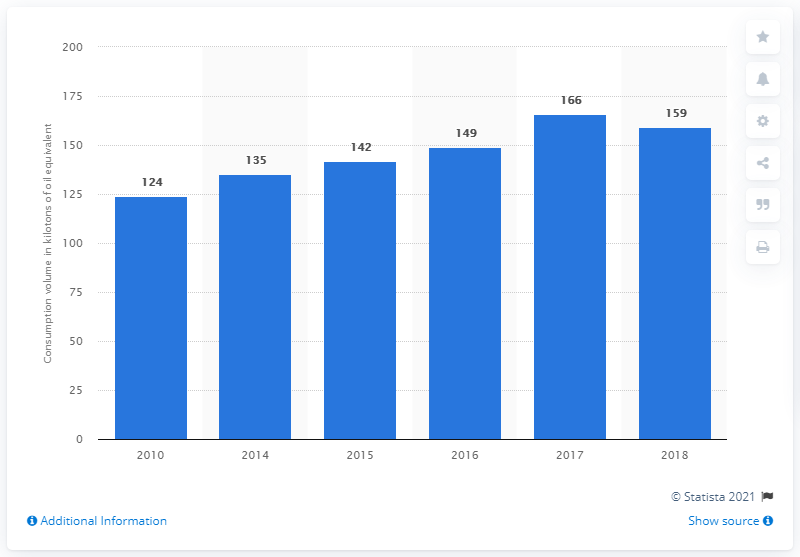Identify some key points in this picture. The difference in the growth rate of consumption between 2010/2014 and 2014/2015 is 4%. In 2018, the volume of biodiesel consumed in the transport sector in Greece dropped to 159 kilotons of oil equivalent. The question asks for the year that showed an abnormal change in the bar value. In Greece, the volume of biodiesel consumed in the transport sector reached its peak in 2010. 